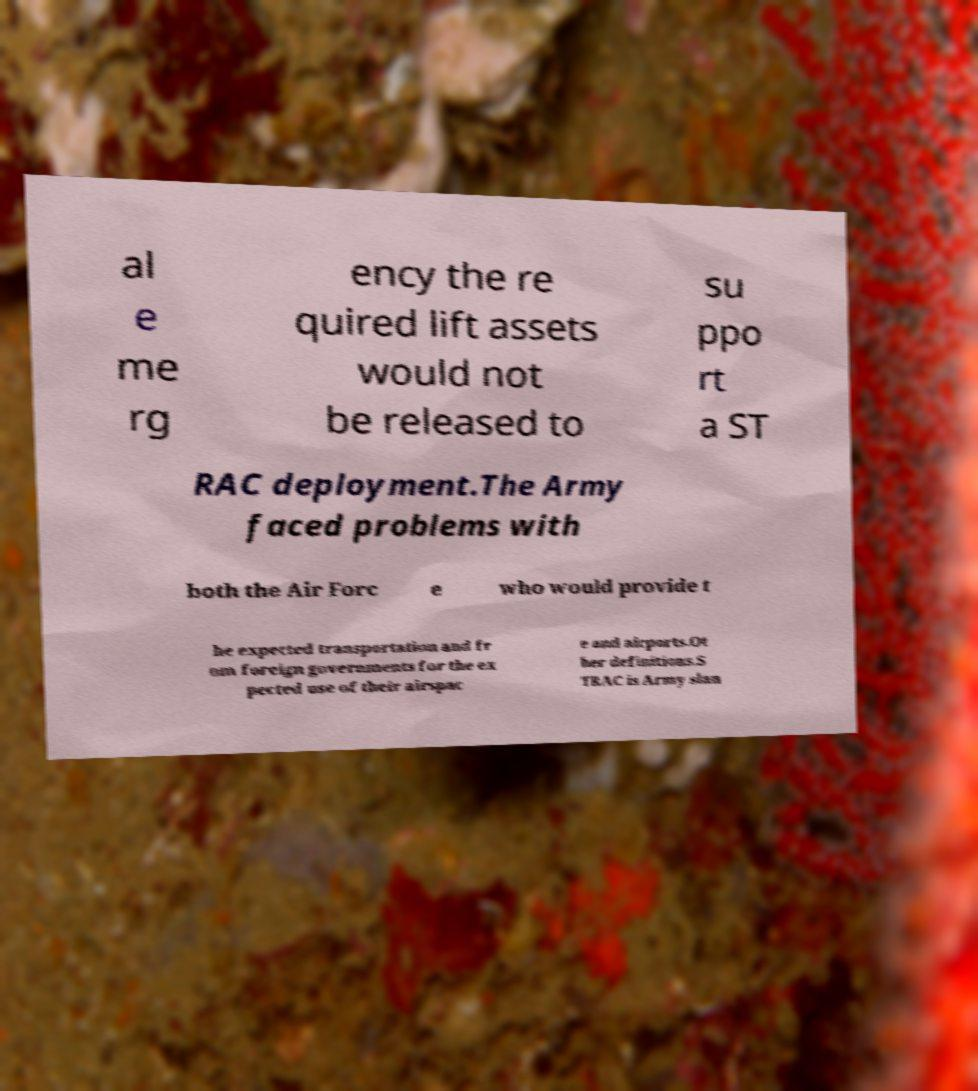There's text embedded in this image that I need extracted. Can you transcribe it verbatim? al e me rg ency the re quired lift assets would not be released to su ppo rt a ST RAC deployment.The Army faced problems with both the Air Forc e who would provide t he expected transportation and fr om foreign governments for the ex pected use of their airspac e and airports.Ot her definitions.S TRAC is Army slan 